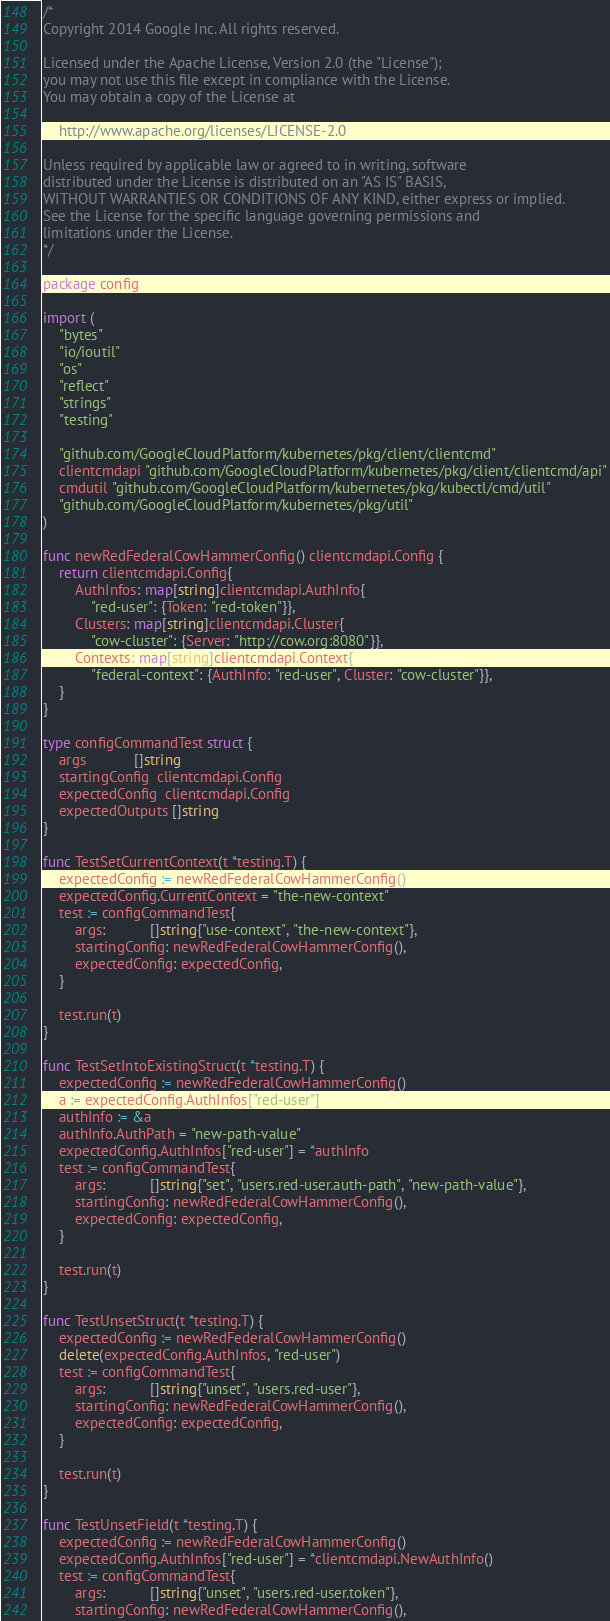Convert code to text. <code><loc_0><loc_0><loc_500><loc_500><_Go_>/*
Copyright 2014 Google Inc. All rights reserved.

Licensed under the Apache License, Version 2.0 (the "License");
you may not use this file except in compliance with the License.
You may obtain a copy of the License at

    http://www.apache.org/licenses/LICENSE-2.0

Unless required by applicable law or agreed to in writing, software
distributed under the License is distributed on an "AS IS" BASIS,
WITHOUT WARRANTIES OR CONDITIONS OF ANY KIND, either express or implied.
See the License for the specific language governing permissions and
limitations under the License.
*/

package config

import (
	"bytes"
	"io/ioutil"
	"os"
	"reflect"
	"strings"
	"testing"

	"github.com/GoogleCloudPlatform/kubernetes/pkg/client/clientcmd"
	clientcmdapi "github.com/GoogleCloudPlatform/kubernetes/pkg/client/clientcmd/api"
	cmdutil "github.com/GoogleCloudPlatform/kubernetes/pkg/kubectl/cmd/util"
	"github.com/GoogleCloudPlatform/kubernetes/pkg/util"
)

func newRedFederalCowHammerConfig() clientcmdapi.Config {
	return clientcmdapi.Config{
		AuthInfos: map[string]clientcmdapi.AuthInfo{
			"red-user": {Token: "red-token"}},
		Clusters: map[string]clientcmdapi.Cluster{
			"cow-cluster": {Server: "http://cow.org:8080"}},
		Contexts: map[string]clientcmdapi.Context{
			"federal-context": {AuthInfo: "red-user", Cluster: "cow-cluster"}},
	}
}

type configCommandTest struct {
	args            []string
	startingConfig  clientcmdapi.Config
	expectedConfig  clientcmdapi.Config
	expectedOutputs []string
}

func TestSetCurrentContext(t *testing.T) {
	expectedConfig := newRedFederalCowHammerConfig()
	expectedConfig.CurrentContext = "the-new-context"
	test := configCommandTest{
		args:           []string{"use-context", "the-new-context"},
		startingConfig: newRedFederalCowHammerConfig(),
		expectedConfig: expectedConfig,
	}

	test.run(t)
}

func TestSetIntoExistingStruct(t *testing.T) {
	expectedConfig := newRedFederalCowHammerConfig()
	a := expectedConfig.AuthInfos["red-user"]
	authInfo := &a
	authInfo.AuthPath = "new-path-value"
	expectedConfig.AuthInfos["red-user"] = *authInfo
	test := configCommandTest{
		args:           []string{"set", "users.red-user.auth-path", "new-path-value"},
		startingConfig: newRedFederalCowHammerConfig(),
		expectedConfig: expectedConfig,
	}

	test.run(t)
}

func TestUnsetStruct(t *testing.T) {
	expectedConfig := newRedFederalCowHammerConfig()
	delete(expectedConfig.AuthInfos, "red-user")
	test := configCommandTest{
		args:           []string{"unset", "users.red-user"},
		startingConfig: newRedFederalCowHammerConfig(),
		expectedConfig: expectedConfig,
	}

	test.run(t)
}

func TestUnsetField(t *testing.T) {
	expectedConfig := newRedFederalCowHammerConfig()
	expectedConfig.AuthInfos["red-user"] = *clientcmdapi.NewAuthInfo()
	test := configCommandTest{
		args:           []string{"unset", "users.red-user.token"},
		startingConfig: newRedFederalCowHammerConfig(),</code> 